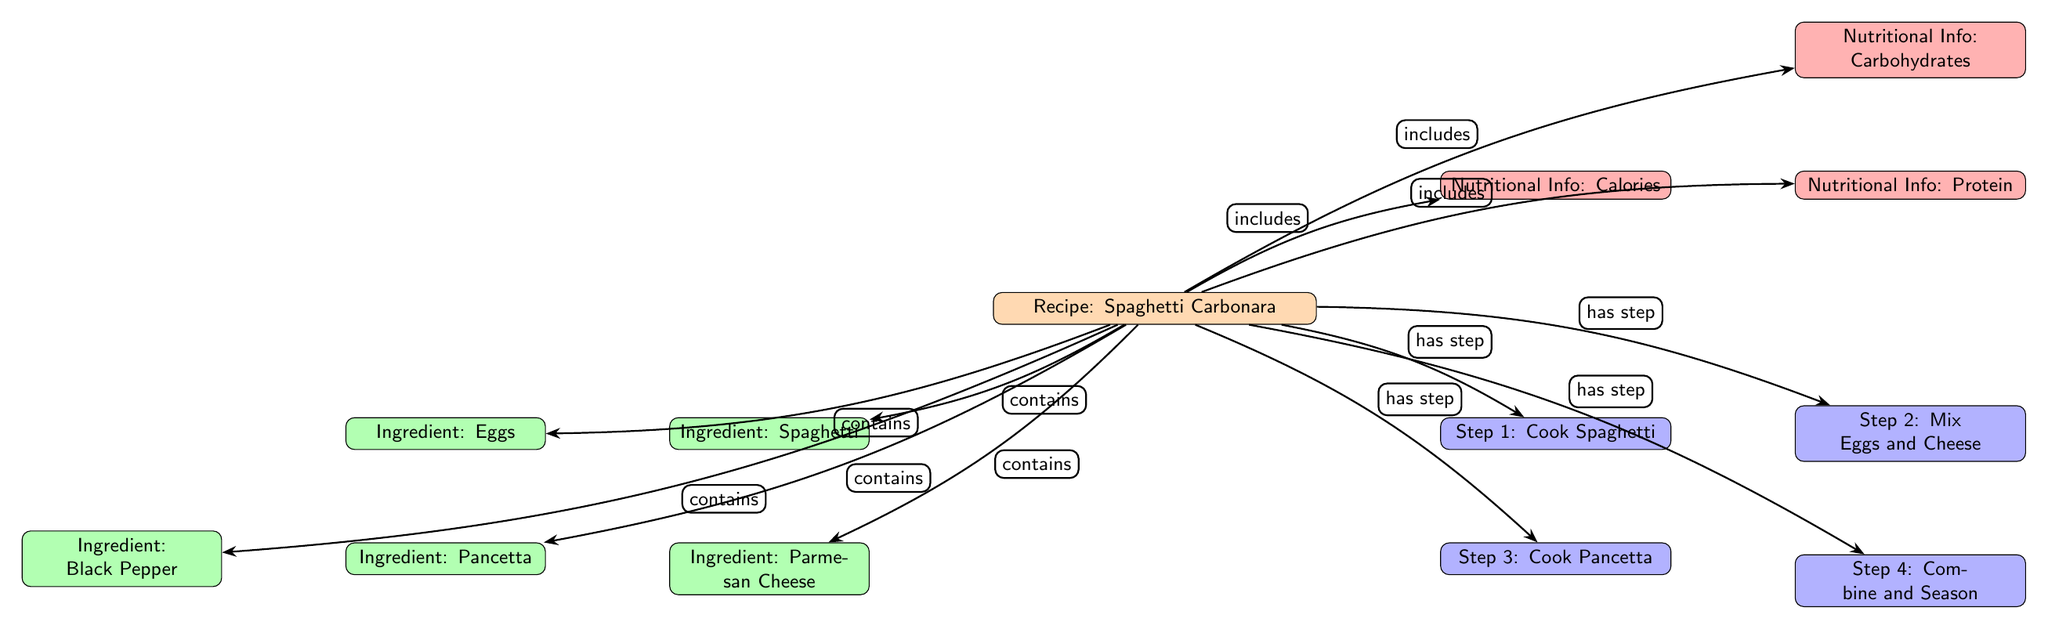What is the main recipe depicted in the diagram? The diagram identifies "Spaghetti Carbonara" as the main recipe, which is clearly labeled at the top.
Answer: Spaghetti Carbonara How many ingredients are listed for the recipe? By counting the ingredient nodes connected to the recipe node, there are five ingredients: Spaghetti, Eggs, Parmesan Cheese, Pancetta, and Black Pepper.
Answer: Five What preparation step follows "Cook Spaghetti"? Referring to the preparation nodes, "Mix Eggs and Cheese" directly follows "Cook Spaghetti."
Answer: Mix Eggs and Cheese Which ingredient is NOT a main ingredient in the recipe? Reviewing the ingredients listed, Black Pepper is included but is not one of the primary ingredients like Spaghetti, Eggs, Parmesan Cheese, or Pancetta.
Answer: Black Pepper What type of relationship connects the recipe to its ingredients? The diagram indicates a "contains" relationship between the recipe and each of its listed ingredients, which is explicitly shown by the arrow labels.
Answer: contains How many nutritional information types are associated with the recipe? The diagram shows three types of nutritional information linked to the recipe: Calories, Protein, and Carbohydrates, as indicated by the nodes connected to the recipe.
Answer: Three Identify the last preparation step in the diagram. The preparation steps are structured sequentially, with "Combine and Season" being the last step listed in the diagram.
Answer: Combine and Season Which ingredient is directly linked to the preparation step "Cook Pancetta"? The ingredient "Pancetta" is clearly associated with the preparation step "Cook Pancetta" according to the edge connecting them in the diagram.
Answer: Pancetta What is the nutritional information type depicted above "Calories"? In the diagram, "Protein" is the nutritional information type that is placed directly to the right of "Calories," indicating it's the next piece of nutritional data.
Answer: Protein 